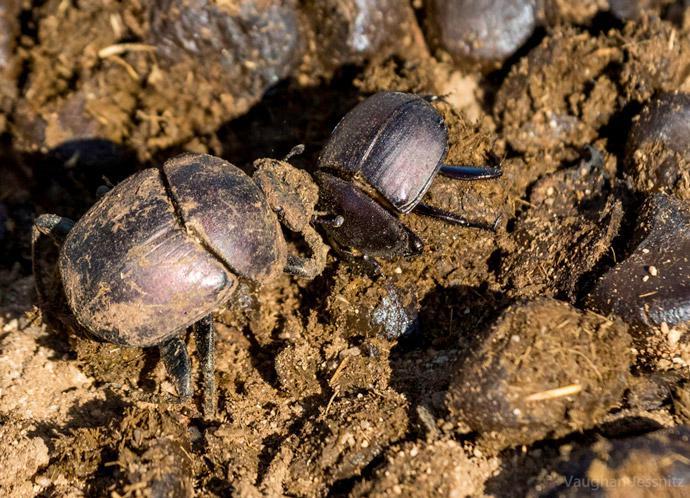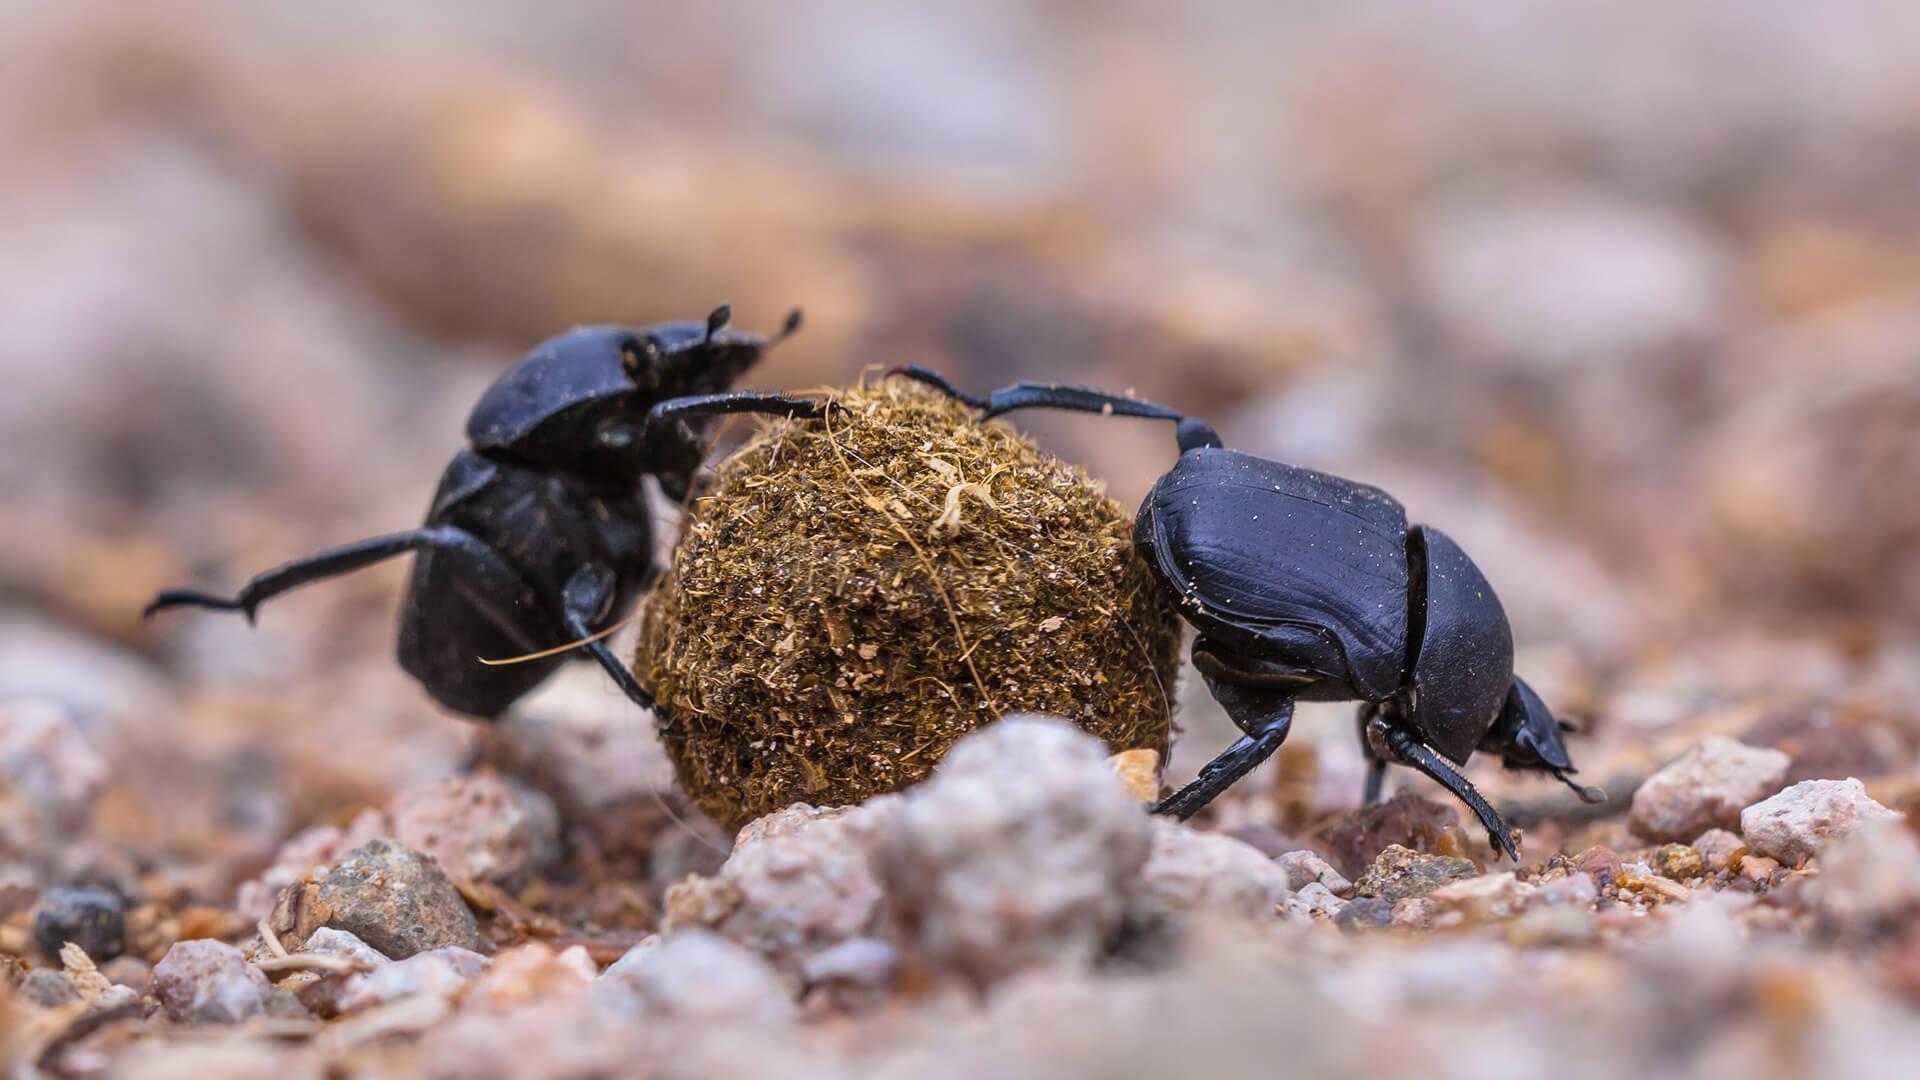The first image is the image on the left, the second image is the image on the right. For the images displayed, is the sentence "There are two beetles on the clod of dirt in the image on the right." factually correct? Answer yes or no. Yes. 